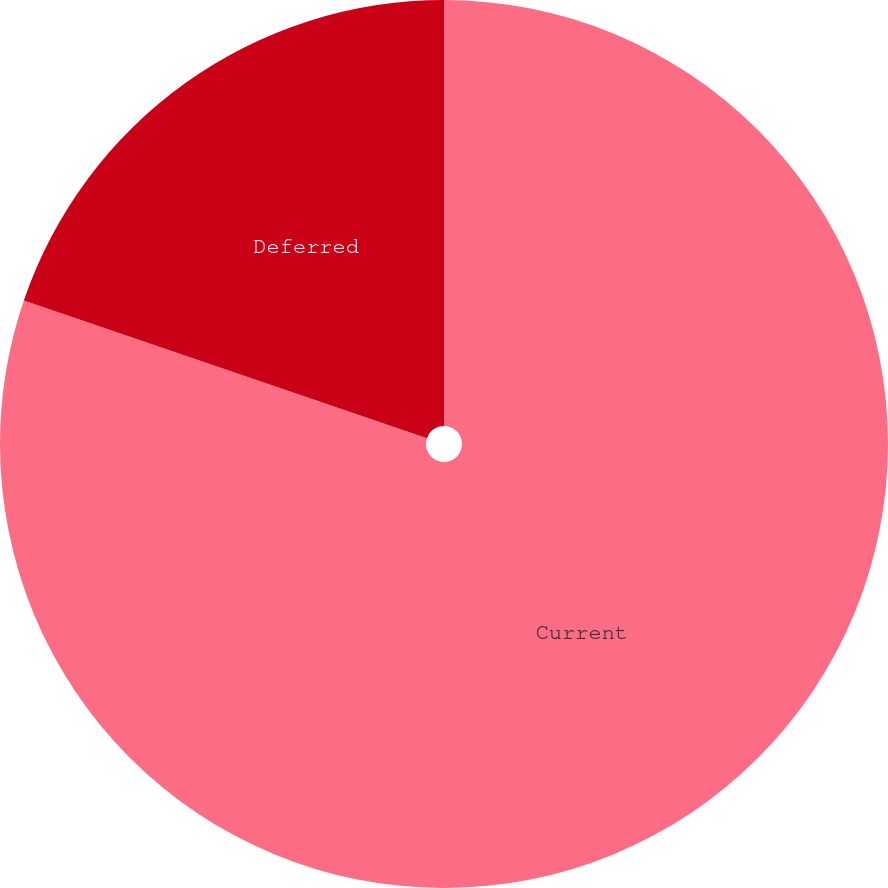Convert chart to OTSL. <chart><loc_0><loc_0><loc_500><loc_500><pie_chart><fcel>Current<fcel>Deferred<nl><fcel>80.24%<fcel>19.76%<nl></chart> 